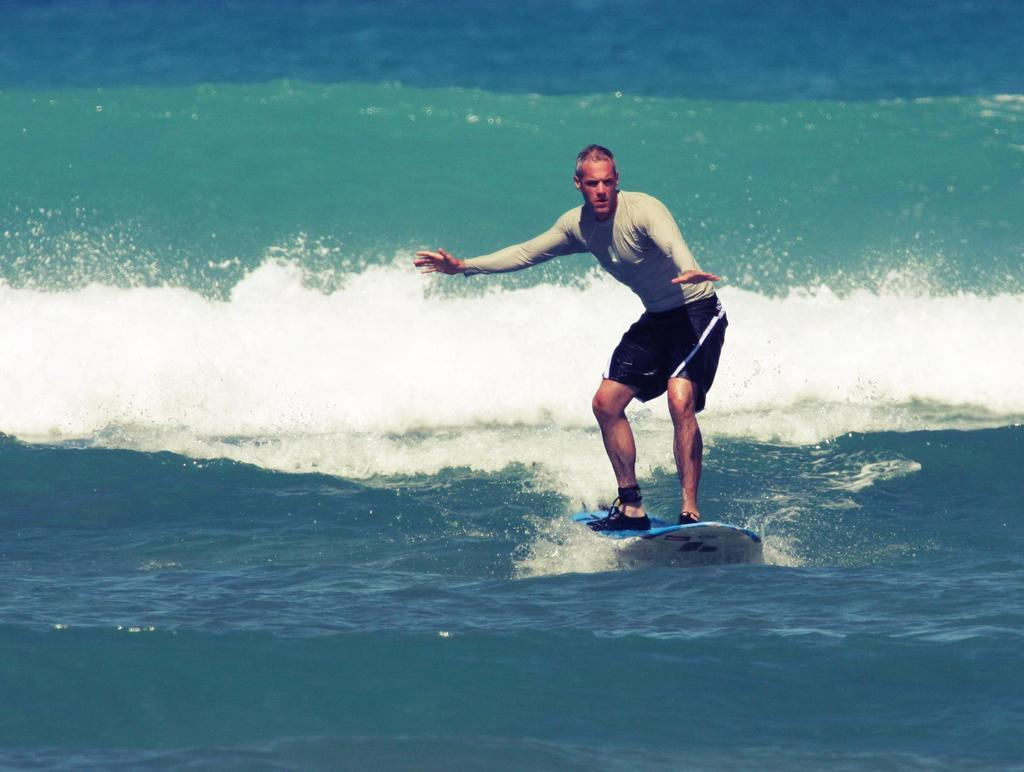Who is the main subject in the image? There is a man in the image. What is the man doing in the image? The man is on a sky board. What can be seen in the background of the image? There are waves visible in the background of the image. What color is the man's shirt in the image? The provided facts do not mention the color of the man's shirt, so we cannot determine the color of his shirt from the image. How many times does the man roll on the sky board in the image? The provided facts do not mention the man rolling on the sky board, so we cannot determine if he rolls or how many times he does so in the image. 